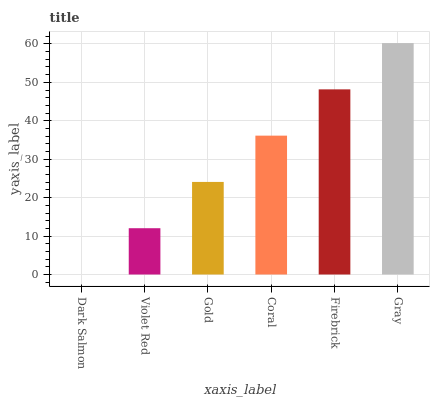Is Dark Salmon the minimum?
Answer yes or no. Yes. Is Gray the maximum?
Answer yes or no. Yes. Is Violet Red the minimum?
Answer yes or no. No. Is Violet Red the maximum?
Answer yes or no. No. Is Violet Red greater than Dark Salmon?
Answer yes or no. Yes. Is Dark Salmon less than Violet Red?
Answer yes or no. Yes. Is Dark Salmon greater than Violet Red?
Answer yes or no. No. Is Violet Red less than Dark Salmon?
Answer yes or no. No. Is Coral the high median?
Answer yes or no. Yes. Is Gold the low median?
Answer yes or no. Yes. Is Gold the high median?
Answer yes or no. No. Is Dark Salmon the low median?
Answer yes or no. No. 